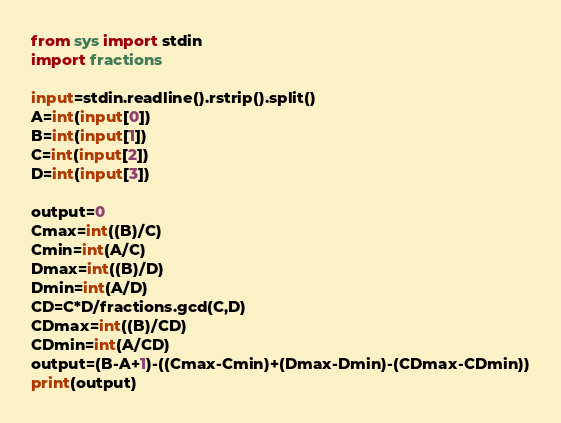Convert code to text. <code><loc_0><loc_0><loc_500><loc_500><_Python_>from sys import stdin
import fractions

input=stdin.readline().rstrip().split()
A=int(input[0])
B=int(input[1])
C=int(input[2])
D=int(input[3])

output=0
Cmax=int((B)/C)
Cmin=int(A/C)
Dmax=int((B)/D)
Dmin=int(A/D)
CD=C*D/fractions.gcd(C,D)
CDmax=int((B)/CD)
CDmin=int(A/CD)
output=(B-A+1)-((Cmax-Cmin)+(Dmax-Dmin)-(CDmax-CDmin))
print(output)</code> 